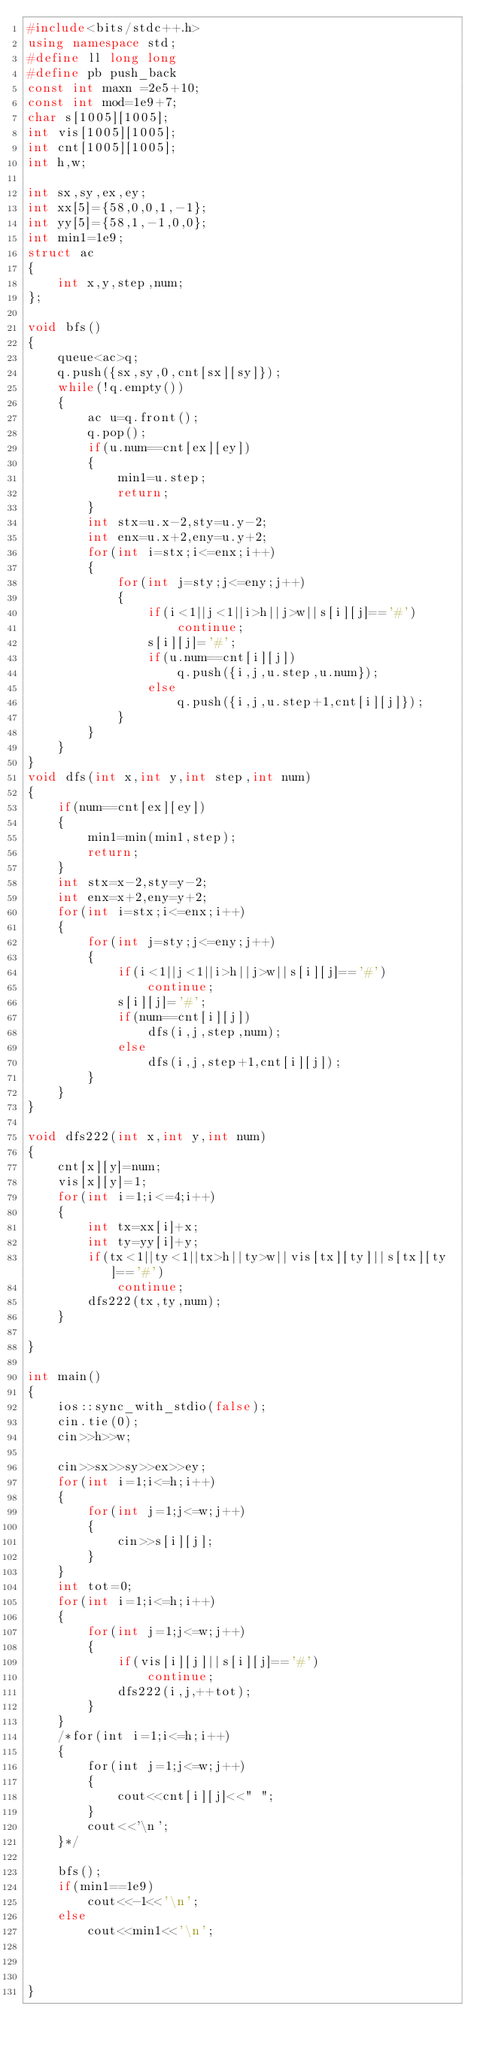Convert code to text. <code><loc_0><loc_0><loc_500><loc_500><_C++_>#include<bits/stdc++.h>
using namespace std;
#define ll long long
#define pb push_back
const int maxn =2e5+10;
const int mod=1e9+7;
char s[1005][1005];
int vis[1005][1005];
int cnt[1005][1005];
int h,w;

int sx,sy,ex,ey;
int xx[5]={58,0,0,1,-1};
int yy[5]={58,1,-1,0,0};
int min1=1e9;
struct ac
{
    int x,y,step,num;
};

void bfs()
{
    queue<ac>q;
    q.push({sx,sy,0,cnt[sx][sy]});
    while(!q.empty())
    {
        ac u=q.front();
        q.pop();
        if(u.num==cnt[ex][ey])
        {
            min1=u.step;
            return;
        }
        int stx=u.x-2,sty=u.y-2;
        int enx=u.x+2,eny=u.y+2;
        for(int i=stx;i<=enx;i++)
        {
            for(int j=sty;j<=eny;j++)
            {
                if(i<1||j<1||i>h||j>w||s[i][j]=='#')
                    continue;
                s[i][j]='#';
                if(u.num==cnt[i][j])
                    q.push({i,j,u.step,u.num});
                else
                    q.push({i,j,u.step+1,cnt[i][j]});
            }
        }
    }
}
void dfs(int x,int y,int step,int num)
{
    if(num==cnt[ex][ey])
    {
        min1=min(min1,step);
        return;
    }
    int stx=x-2,sty=y-2;
    int enx=x+2,eny=y+2;
    for(int i=stx;i<=enx;i++)
    {
        for(int j=sty;j<=eny;j++)
        {
            if(i<1||j<1||i>h||j>w||s[i][j]=='#')
                continue;
            s[i][j]='#';
            if(num==cnt[i][j])
                dfs(i,j,step,num);
            else
                dfs(i,j,step+1,cnt[i][j]);
        }
    }
}

void dfs222(int x,int y,int num)
{
    cnt[x][y]=num;
    vis[x][y]=1;
    for(int i=1;i<=4;i++)
    {
        int tx=xx[i]+x;
        int ty=yy[i]+y;
        if(tx<1||ty<1||tx>h||ty>w||vis[tx][ty]||s[tx][ty]=='#')
            continue;
        dfs222(tx,ty,num);
    }

}

int main()
{
    ios::sync_with_stdio(false);
    cin.tie(0);
    cin>>h>>w;

    cin>>sx>>sy>>ex>>ey;
    for(int i=1;i<=h;i++)
    {
        for(int j=1;j<=w;j++)
        {
            cin>>s[i][j];
        }
    }
    int tot=0;
    for(int i=1;i<=h;i++)
    {
        for(int j=1;j<=w;j++)
        {
            if(vis[i][j]||s[i][j]=='#')
                continue;
            dfs222(i,j,++tot);
        }
    }
    /*for(int i=1;i<=h;i++)
    {
        for(int j=1;j<=w;j++)
        {
            cout<<cnt[i][j]<<" ";
        }
        cout<<'\n';
    }*/

    bfs();
    if(min1==1e9)
        cout<<-1<<'\n';
    else
        cout<<min1<<'\n';



}
</code> 